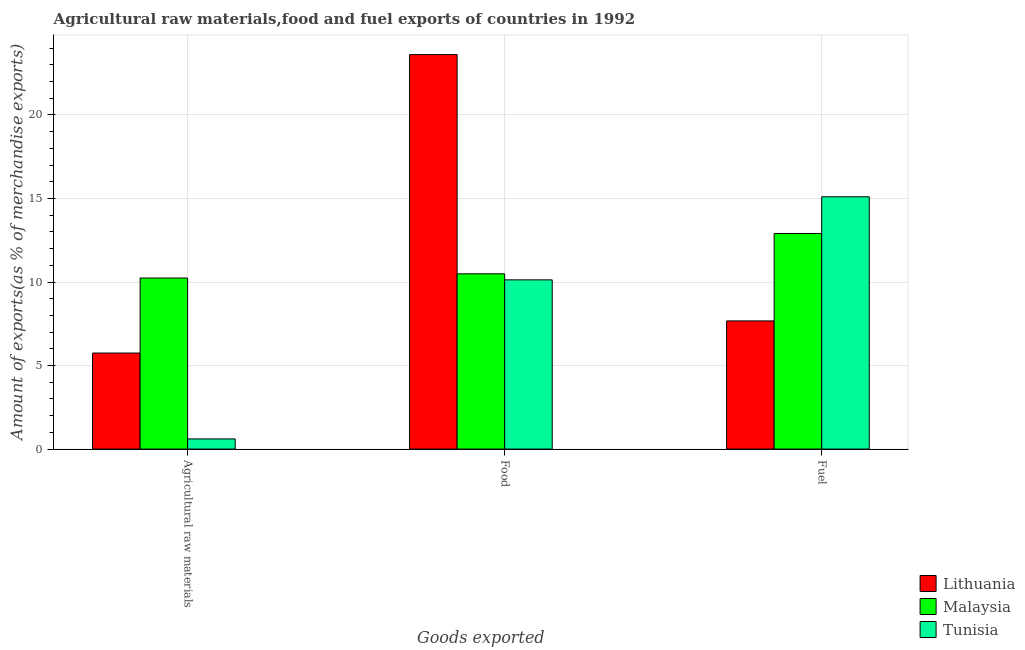How many different coloured bars are there?
Keep it short and to the point. 3. Are the number of bars per tick equal to the number of legend labels?
Provide a succinct answer. Yes. Are the number of bars on each tick of the X-axis equal?
Offer a very short reply. Yes. How many bars are there on the 3rd tick from the left?
Give a very brief answer. 3. How many bars are there on the 3rd tick from the right?
Make the answer very short. 3. What is the label of the 1st group of bars from the left?
Provide a succinct answer. Agricultural raw materials. What is the percentage of fuel exports in Tunisia?
Your answer should be compact. 15.1. Across all countries, what is the maximum percentage of food exports?
Your response must be concise. 23.61. Across all countries, what is the minimum percentage of raw materials exports?
Give a very brief answer. 0.61. In which country was the percentage of food exports maximum?
Provide a succinct answer. Lithuania. In which country was the percentage of food exports minimum?
Offer a terse response. Tunisia. What is the total percentage of raw materials exports in the graph?
Ensure brevity in your answer.  16.59. What is the difference between the percentage of raw materials exports in Malaysia and that in Tunisia?
Give a very brief answer. 9.63. What is the difference between the percentage of fuel exports in Lithuania and the percentage of food exports in Malaysia?
Ensure brevity in your answer.  -2.82. What is the average percentage of food exports per country?
Provide a succinct answer. 14.74. What is the difference between the percentage of raw materials exports and percentage of fuel exports in Tunisia?
Make the answer very short. -14.49. What is the ratio of the percentage of raw materials exports in Tunisia to that in Lithuania?
Keep it short and to the point. 0.11. Is the percentage of food exports in Lithuania less than that in Malaysia?
Your answer should be very brief. No. What is the difference between the highest and the second highest percentage of raw materials exports?
Provide a succinct answer. 4.49. What is the difference between the highest and the lowest percentage of raw materials exports?
Keep it short and to the point. 9.63. Is the sum of the percentage of food exports in Tunisia and Lithuania greater than the maximum percentage of fuel exports across all countries?
Ensure brevity in your answer.  Yes. What does the 1st bar from the left in Agricultural raw materials represents?
Provide a succinct answer. Lithuania. What does the 3rd bar from the right in Food represents?
Your response must be concise. Lithuania. Is it the case that in every country, the sum of the percentage of raw materials exports and percentage of food exports is greater than the percentage of fuel exports?
Provide a succinct answer. No. How many bars are there?
Keep it short and to the point. 9. What is the difference between two consecutive major ticks on the Y-axis?
Your response must be concise. 5. Does the graph contain any zero values?
Keep it short and to the point. No. Does the graph contain grids?
Make the answer very short. Yes. Where does the legend appear in the graph?
Ensure brevity in your answer.  Bottom right. How many legend labels are there?
Provide a succinct answer. 3. What is the title of the graph?
Offer a very short reply. Agricultural raw materials,food and fuel exports of countries in 1992. What is the label or title of the X-axis?
Your response must be concise. Goods exported. What is the label or title of the Y-axis?
Make the answer very short. Amount of exports(as % of merchandise exports). What is the Amount of exports(as % of merchandise exports) of Lithuania in Agricultural raw materials?
Offer a very short reply. 5.75. What is the Amount of exports(as % of merchandise exports) in Malaysia in Agricultural raw materials?
Give a very brief answer. 10.24. What is the Amount of exports(as % of merchandise exports) in Tunisia in Agricultural raw materials?
Your answer should be compact. 0.61. What is the Amount of exports(as % of merchandise exports) in Lithuania in Food?
Ensure brevity in your answer.  23.61. What is the Amount of exports(as % of merchandise exports) in Malaysia in Food?
Your answer should be very brief. 10.49. What is the Amount of exports(as % of merchandise exports) in Tunisia in Food?
Your answer should be very brief. 10.13. What is the Amount of exports(as % of merchandise exports) of Lithuania in Fuel?
Give a very brief answer. 7.67. What is the Amount of exports(as % of merchandise exports) in Malaysia in Fuel?
Your answer should be compact. 12.91. What is the Amount of exports(as % of merchandise exports) in Tunisia in Fuel?
Provide a short and direct response. 15.1. Across all Goods exported, what is the maximum Amount of exports(as % of merchandise exports) of Lithuania?
Provide a short and direct response. 23.61. Across all Goods exported, what is the maximum Amount of exports(as % of merchandise exports) in Malaysia?
Keep it short and to the point. 12.91. Across all Goods exported, what is the maximum Amount of exports(as % of merchandise exports) in Tunisia?
Your answer should be very brief. 15.1. Across all Goods exported, what is the minimum Amount of exports(as % of merchandise exports) in Lithuania?
Your response must be concise. 5.75. Across all Goods exported, what is the minimum Amount of exports(as % of merchandise exports) in Malaysia?
Ensure brevity in your answer.  10.24. Across all Goods exported, what is the minimum Amount of exports(as % of merchandise exports) of Tunisia?
Make the answer very short. 0.61. What is the total Amount of exports(as % of merchandise exports) of Lithuania in the graph?
Your answer should be compact. 37.03. What is the total Amount of exports(as % of merchandise exports) in Malaysia in the graph?
Your answer should be compact. 33.63. What is the total Amount of exports(as % of merchandise exports) in Tunisia in the graph?
Keep it short and to the point. 25.84. What is the difference between the Amount of exports(as % of merchandise exports) in Lithuania in Agricultural raw materials and that in Food?
Offer a very short reply. -17.86. What is the difference between the Amount of exports(as % of merchandise exports) of Malaysia in Agricultural raw materials and that in Food?
Offer a very short reply. -0.25. What is the difference between the Amount of exports(as % of merchandise exports) of Tunisia in Agricultural raw materials and that in Food?
Give a very brief answer. -9.52. What is the difference between the Amount of exports(as % of merchandise exports) in Lithuania in Agricultural raw materials and that in Fuel?
Provide a succinct answer. -1.92. What is the difference between the Amount of exports(as % of merchandise exports) of Malaysia in Agricultural raw materials and that in Fuel?
Your response must be concise. -2.67. What is the difference between the Amount of exports(as % of merchandise exports) in Tunisia in Agricultural raw materials and that in Fuel?
Your response must be concise. -14.49. What is the difference between the Amount of exports(as % of merchandise exports) of Lithuania in Food and that in Fuel?
Offer a terse response. 15.94. What is the difference between the Amount of exports(as % of merchandise exports) in Malaysia in Food and that in Fuel?
Provide a short and direct response. -2.42. What is the difference between the Amount of exports(as % of merchandise exports) in Tunisia in Food and that in Fuel?
Your response must be concise. -4.97. What is the difference between the Amount of exports(as % of merchandise exports) of Lithuania in Agricultural raw materials and the Amount of exports(as % of merchandise exports) of Malaysia in Food?
Offer a terse response. -4.74. What is the difference between the Amount of exports(as % of merchandise exports) of Lithuania in Agricultural raw materials and the Amount of exports(as % of merchandise exports) of Tunisia in Food?
Provide a short and direct response. -4.38. What is the difference between the Amount of exports(as % of merchandise exports) in Malaysia in Agricultural raw materials and the Amount of exports(as % of merchandise exports) in Tunisia in Food?
Keep it short and to the point. 0.11. What is the difference between the Amount of exports(as % of merchandise exports) in Lithuania in Agricultural raw materials and the Amount of exports(as % of merchandise exports) in Malaysia in Fuel?
Offer a very short reply. -7.16. What is the difference between the Amount of exports(as % of merchandise exports) of Lithuania in Agricultural raw materials and the Amount of exports(as % of merchandise exports) of Tunisia in Fuel?
Make the answer very short. -9.35. What is the difference between the Amount of exports(as % of merchandise exports) in Malaysia in Agricultural raw materials and the Amount of exports(as % of merchandise exports) in Tunisia in Fuel?
Provide a succinct answer. -4.86. What is the difference between the Amount of exports(as % of merchandise exports) of Lithuania in Food and the Amount of exports(as % of merchandise exports) of Malaysia in Fuel?
Your answer should be very brief. 10.71. What is the difference between the Amount of exports(as % of merchandise exports) in Lithuania in Food and the Amount of exports(as % of merchandise exports) in Tunisia in Fuel?
Your answer should be very brief. 8.51. What is the difference between the Amount of exports(as % of merchandise exports) in Malaysia in Food and the Amount of exports(as % of merchandise exports) in Tunisia in Fuel?
Your answer should be very brief. -4.61. What is the average Amount of exports(as % of merchandise exports) in Lithuania per Goods exported?
Give a very brief answer. 12.34. What is the average Amount of exports(as % of merchandise exports) in Malaysia per Goods exported?
Ensure brevity in your answer.  11.21. What is the average Amount of exports(as % of merchandise exports) in Tunisia per Goods exported?
Provide a short and direct response. 8.61. What is the difference between the Amount of exports(as % of merchandise exports) in Lithuania and Amount of exports(as % of merchandise exports) in Malaysia in Agricultural raw materials?
Provide a short and direct response. -4.49. What is the difference between the Amount of exports(as % of merchandise exports) of Lithuania and Amount of exports(as % of merchandise exports) of Tunisia in Agricultural raw materials?
Your answer should be compact. 5.14. What is the difference between the Amount of exports(as % of merchandise exports) in Malaysia and Amount of exports(as % of merchandise exports) in Tunisia in Agricultural raw materials?
Give a very brief answer. 9.63. What is the difference between the Amount of exports(as % of merchandise exports) of Lithuania and Amount of exports(as % of merchandise exports) of Malaysia in Food?
Offer a very short reply. 13.12. What is the difference between the Amount of exports(as % of merchandise exports) of Lithuania and Amount of exports(as % of merchandise exports) of Tunisia in Food?
Offer a very short reply. 13.48. What is the difference between the Amount of exports(as % of merchandise exports) of Malaysia and Amount of exports(as % of merchandise exports) of Tunisia in Food?
Your response must be concise. 0.36. What is the difference between the Amount of exports(as % of merchandise exports) in Lithuania and Amount of exports(as % of merchandise exports) in Malaysia in Fuel?
Make the answer very short. -5.23. What is the difference between the Amount of exports(as % of merchandise exports) in Lithuania and Amount of exports(as % of merchandise exports) in Tunisia in Fuel?
Your answer should be very brief. -7.43. What is the difference between the Amount of exports(as % of merchandise exports) of Malaysia and Amount of exports(as % of merchandise exports) of Tunisia in Fuel?
Give a very brief answer. -2.2. What is the ratio of the Amount of exports(as % of merchandise exports) in Lithuania in Agricultural raw materials to that in Food?
Make the answer very short. 0.24. What is the ratio of the Amount of exports(as % of merchandise exports) in Malaysia in Agricultural raw materials to that in Food?
Offer a terse response. 0.98. What is the ratio of the Amount of exports(as % of merchandise exports) of Tunisia in Agricultural raw materials to that in Food?
Offer a very short reply. 0.06. What is the ratio of the Amount of exports(as % of merchandise exports) in Lithuania in Agricultural raw materials to that in Fuel?
Offer a very short reply. 0.75. What is the ratio of the Amount of exports(as % of merchandise exports) of Malaysia in Agricultural raw materials to that in Fuel?
Provide a short and direct response. 0.79. What is the ratio of the Amount of exports(as % of merchandise exports) of Tunisia in Agricultural raw materials to that in Fuel?
Offer a very short reply. 0.04. What is the ratio of the Amount of exports(as % of merchandise exports) in Lithuania in Food to that in Fuel?
Give a very brief answer. 3.08. What is the ratio of the Amount of exports(as % of merchandise exports) of Malaysia in Food to that in Fuel?
Your answer should be compact. 0.81. What is the ratio of the Amount of exports(as % of merchandise exports) in Tunisia in Food to that in Fuel?
Provide a succinct answer. 0.67. What is the difference between the highest and the second highest Amount of exports(as % of merchandise exports) of Lithuania?
Give a very brief answer. 15.94. What is the difference between the highest and the second highest Amount of exports(as % of merchandise exports) in Malaysia?
Ensure brevity in your answer.  2.42. What is the difference between the highest and the second highest Amount of exports(as % of merchandise exports) in Tunisia?
Give a very brief answer. 4.97. What is the difference between the highest and the lowest Amount of exports(as % of merchandise exports) of Lithuania?
Your response must be concise. 17.86. What is the difference between the highest and the lowest Amount of exports(as % of merchandise exports) of Malaysia?
Offer a terse response. 2.67. What is the difference between the highest and the lowest Amount of exports(as % of merchandise exports) in Tunisia?
Keep it short and to the point. 14.49. 